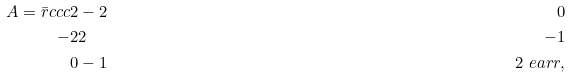<formula> <loc_0><loc_0><loc_500><loc_500>A = \bar { r } { c c c } 2 & - 2 & 0 \\ - 2 & 2 & - 1 \\ 0 & - 1 & 2 \ e a r r ,</formula> 